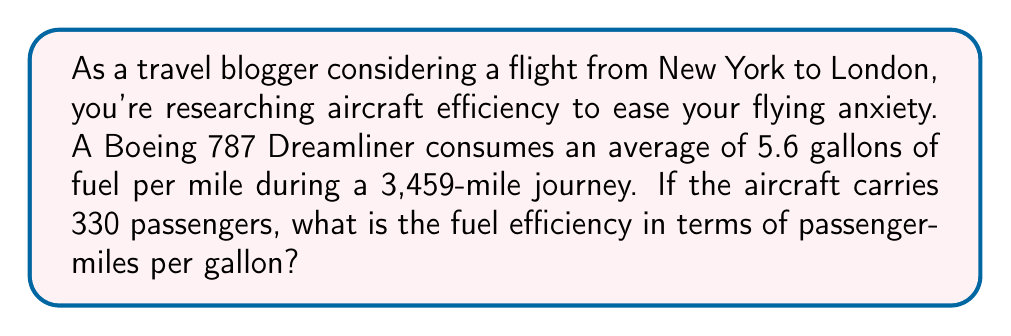Teach me how to tackle this problem. To calculate the fuel efficiency in passenger-miles per gallon, we'll follow these steps:

1. Calculate total fuel consumption for the journey:
   $$\text{Total fuel} = \text{Fuel per mile} \times \text{Distance}$$
   $$\text{Total fuel} = 5.6 \text{ gallons/mile} \times 3,459 \text{ miles} = 19,370.4 \text{ gallons}$$

2. Calculate total passenger-miles:
   $$\text{Passenger-miles} = \text{Number of passengers} \times \text{Distance}$$
   $$\text{Passenger-miles} = 330 \times 3,459 = 1,141,470 \text{ passenger-miles}$$

3. Calculate fuel efficiency in passenger-miles per gallon:
   $$\text{Efficiency} = \frac{\text{Passenger-miles}}{\text{Total fuel}}$$
   $$\text{Efficiency} = \frac{1,141,470 \text{ passenger-miles}}{19,370.4 \text{ gallons}} = 58.93 \text{ passenger-miles/gallon}$$

Therefore, the fuel efficiency of the Boeing 787 Dreamliner for this flight is approximately 58.93 passenger-miles per gallon.
Answer: 58.93 passenger-miles/gallon 